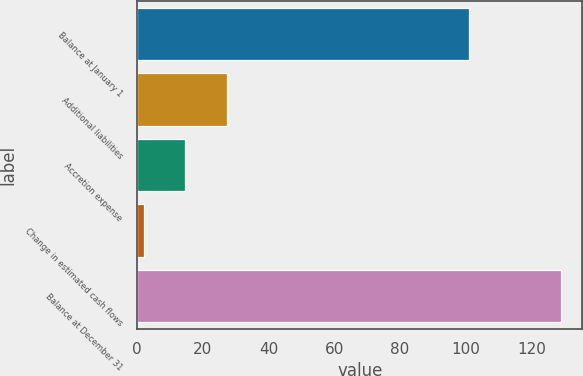Convert chart to OTSL. <chart><loc_0><loc_0><loc_500><loc_500><bar_chart><fcel>Balance at January 1<fcel>Additional liabilities<fcel>Accretion expense<fcel>Change in estimated cash flows<fcel>Balance at December 31<nl><fcel>101<fcel>27.4<fcel>14.7<fcel>2<fcel>129<nl></chart> 